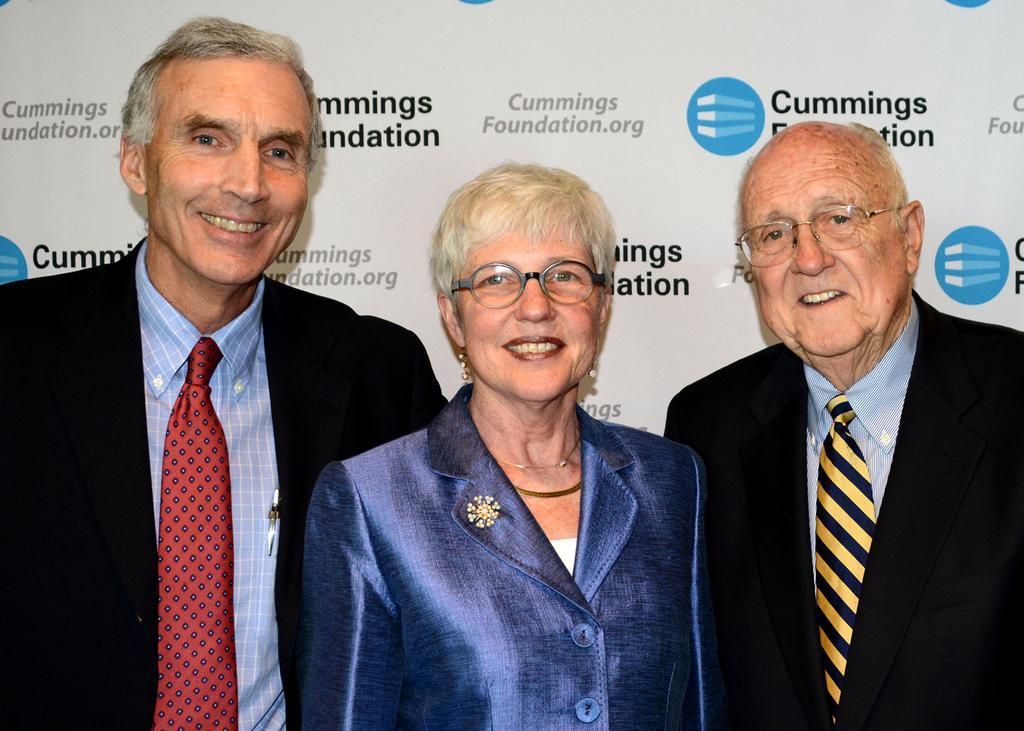Can you describe this image briefly? In the picture we can see two men and a woman standing, and the woman is standing in the middle of them and men are wearing blazers, ties and shirts and woman is wearing a blue coat and they are smiling and behind them we can see a board with a brand names on it. 